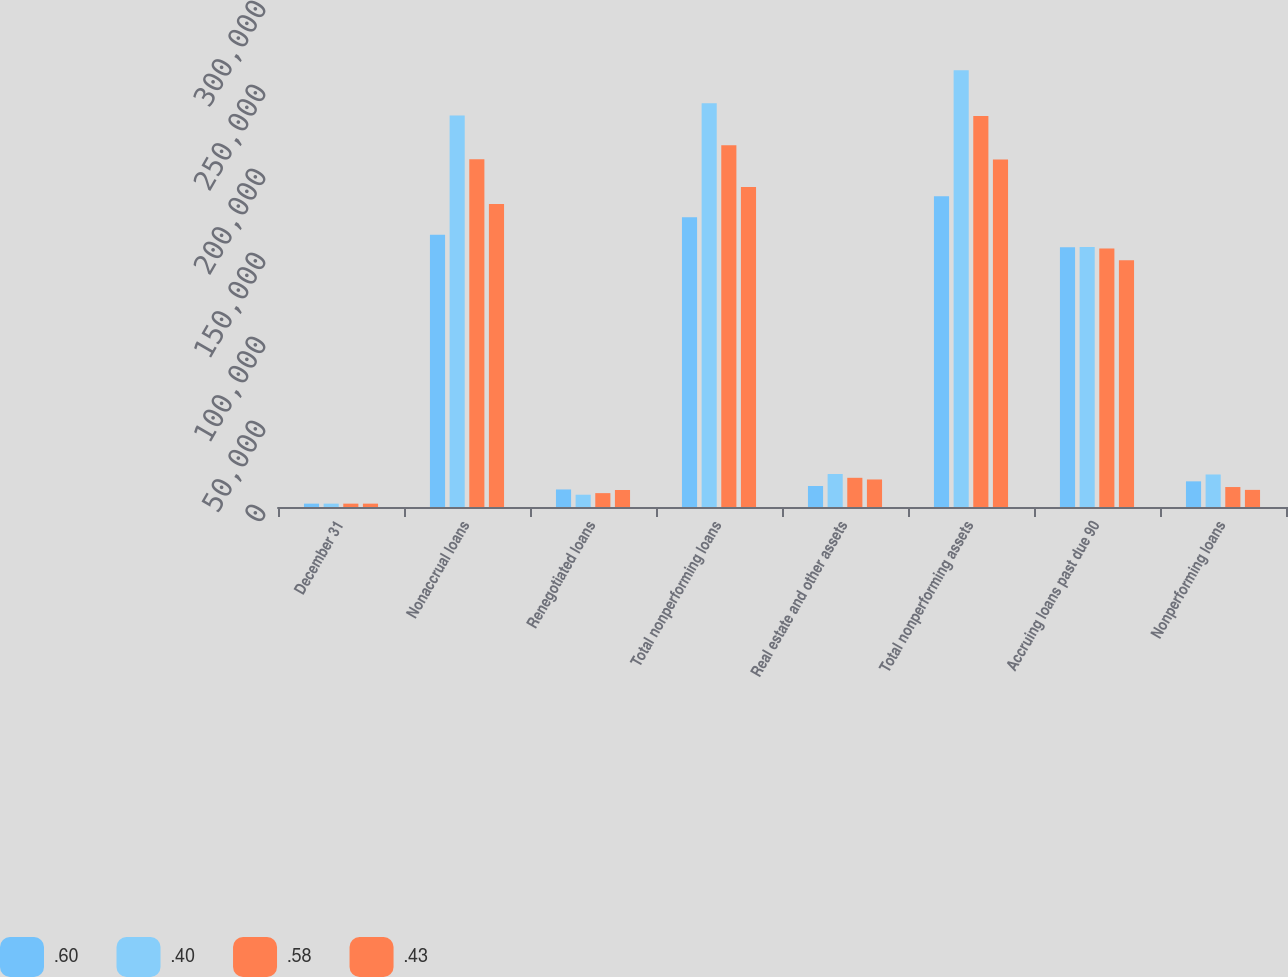Convert chart to OTSL. <chart><loc_0><loc_0><loc_500><loc_500><stacked_bar_chart><ecel><fcel>December 31<fcel>Nonaccrual loans<fcel>Renegotiated loans<fcel>Total nonperforming loans<fcel>Real estate and other assets<fcel>Total nonperforming assets<fcel>Accruing loans past due 90<fcel>Nonperforming loans<nl><fcel>0.6<fcel>2004<fcel>162013<fcel>10437<fcel>172450<fcel>12504<fcel>184954<fcel>154590<fcel>15273<nl><fcel>0.4<fcel>2003<fcel>232983<fcel>7309<fcel>240292<fcel>19629<fcel>259921<fcel>154759<fcel>19355<nl><fcel>0.58<fcel>2002<fcel>207038<fcel>8252<fcel>215290<fcel>17380<fcel>232670<fcel>153803<fcel>11885<nl><fcel>0.43<fcel>2001<fcel>180344<fcel>10128<fcel>190472<fcel>16387<fcel>206859<fcel>146899<fcel>10196<nl></chart> 